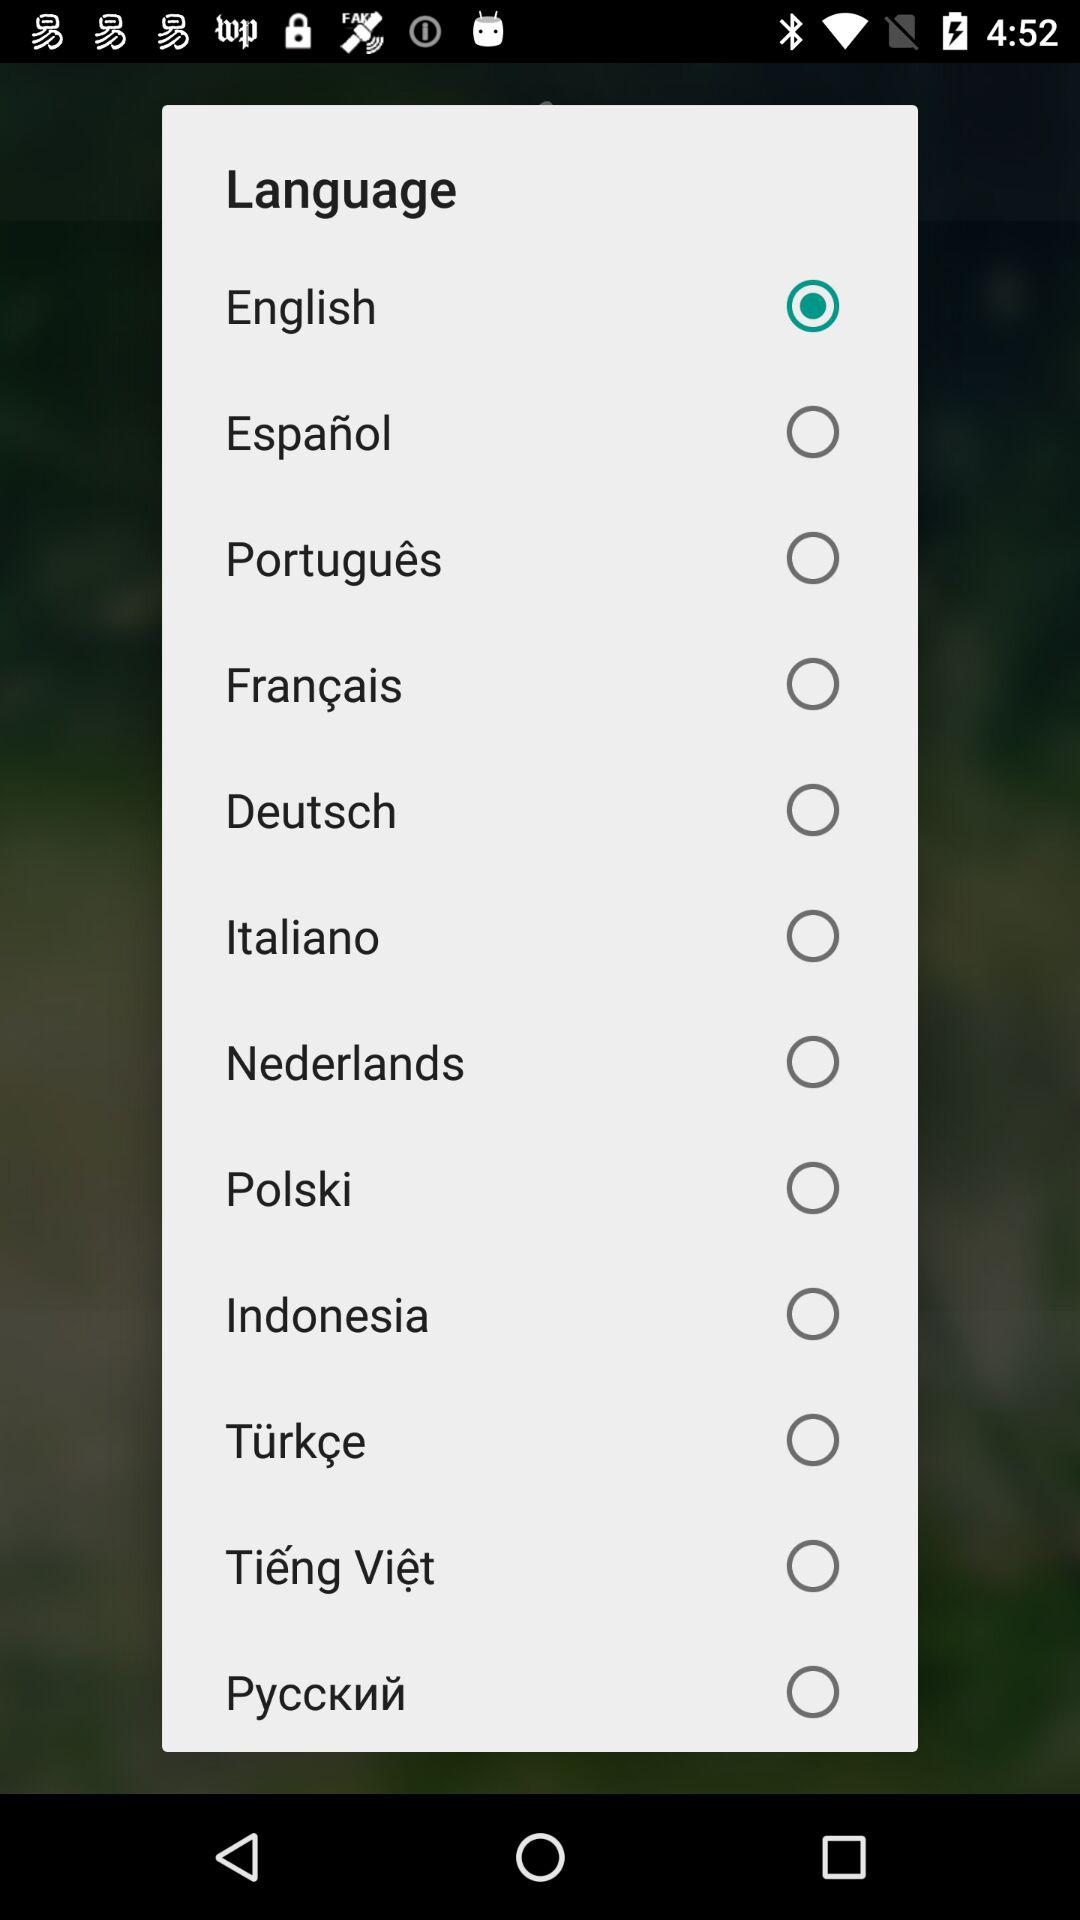What is the name of the application?
When the provided information is insufficient, respond with <no answer>. <no answer> 